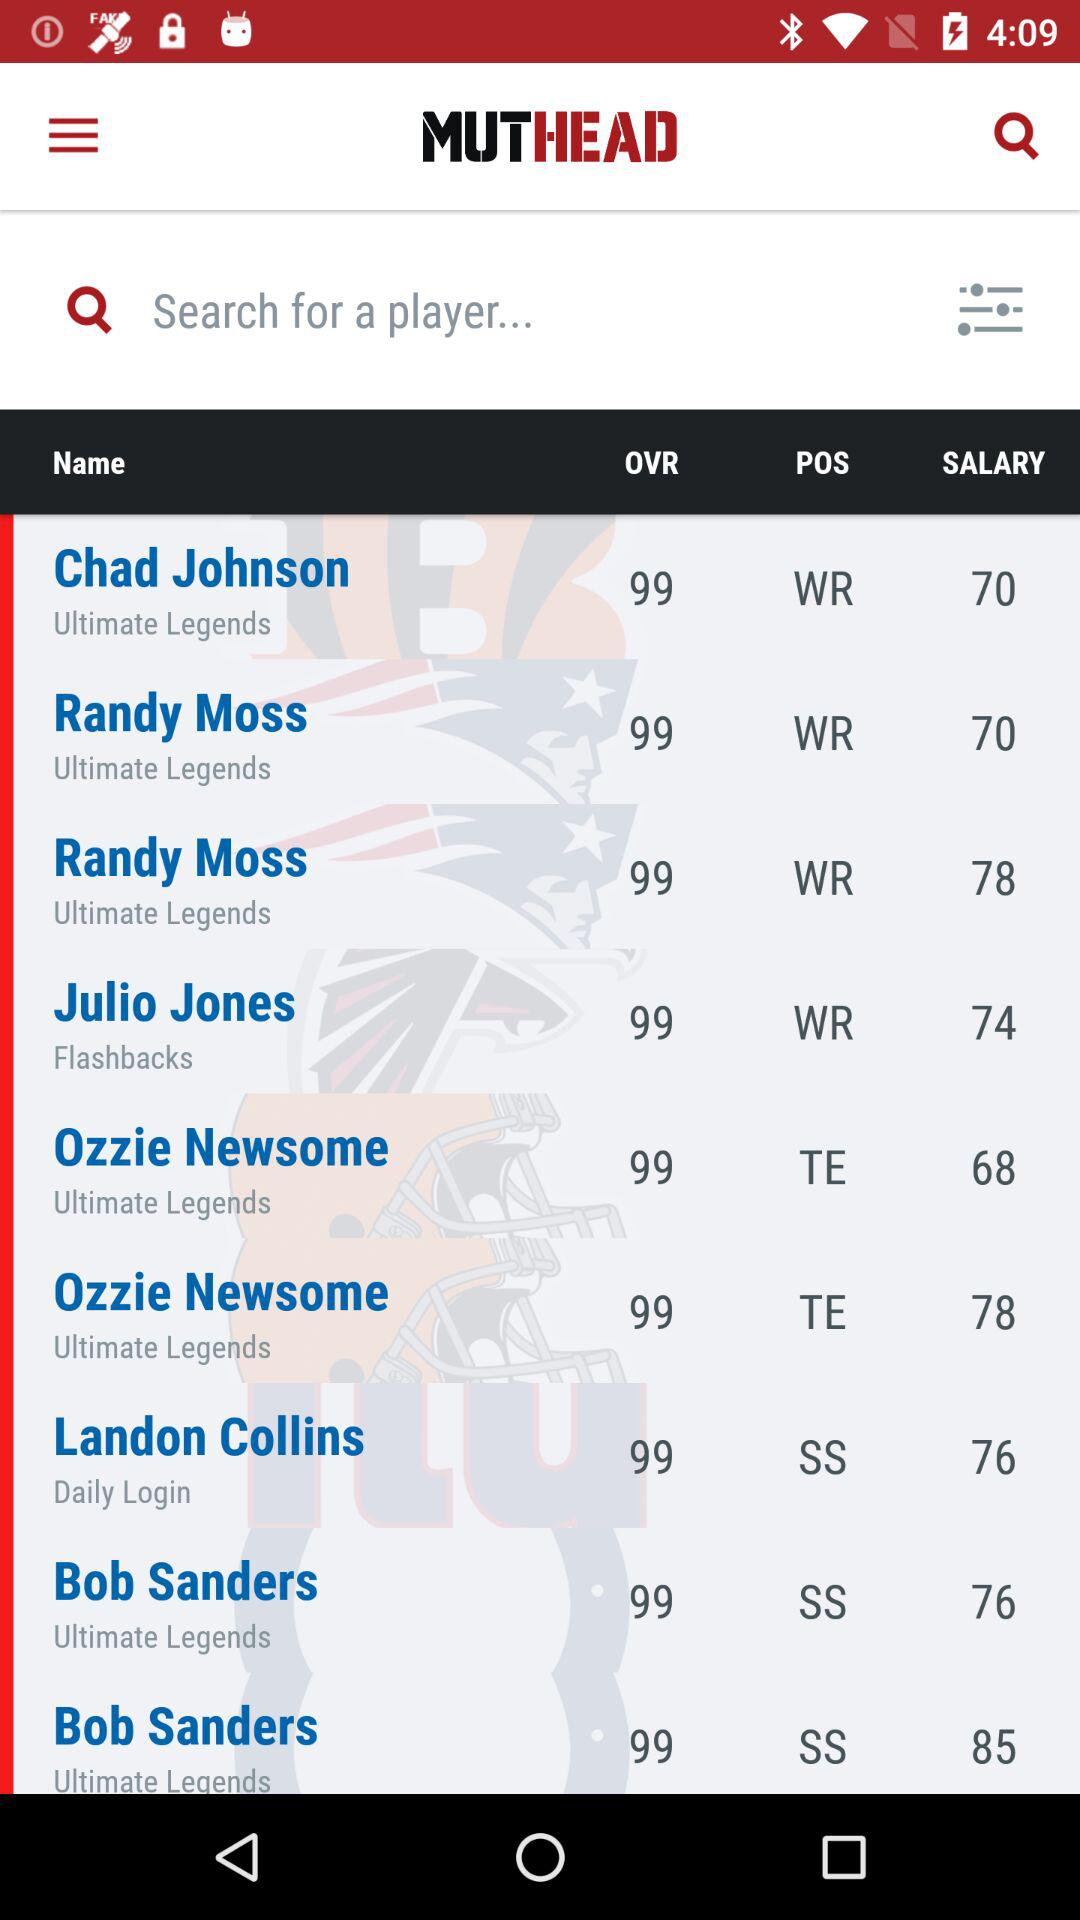How much does Landon Collins earn? Landon Collins earns 76. 